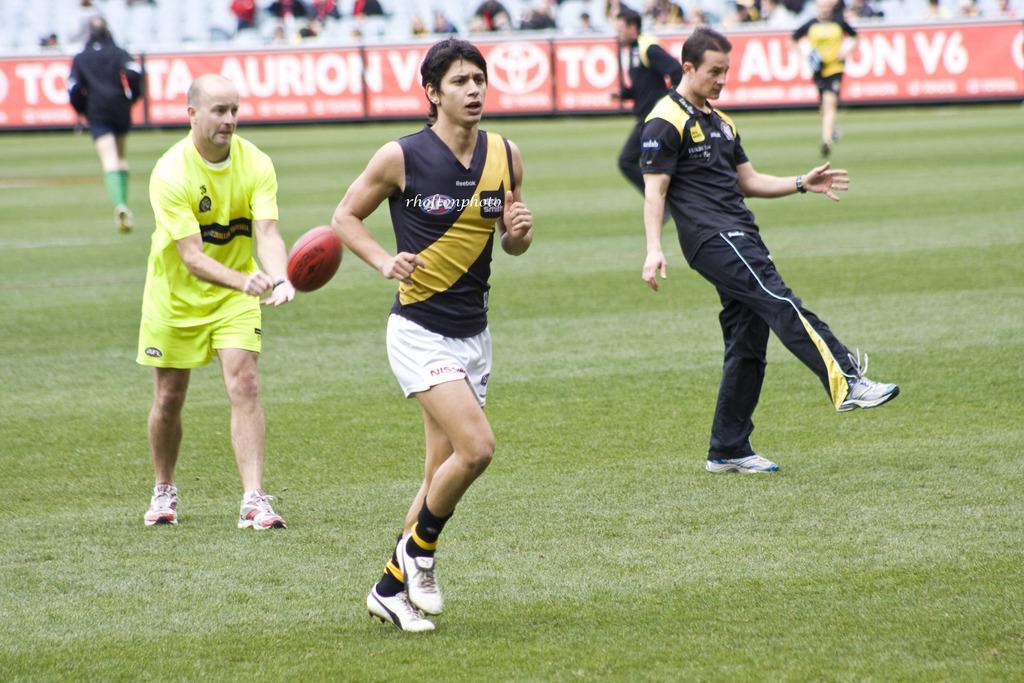Can you describe this image briefly? In the foreground of this picture, there is a man running on the grass and an another person with one leg standing on the grass. On the left side of the image, there is a man standing on the grass and there is a rugby ball in the air. In the background, there are persons running, banner, chairs and persons sitting on it. 